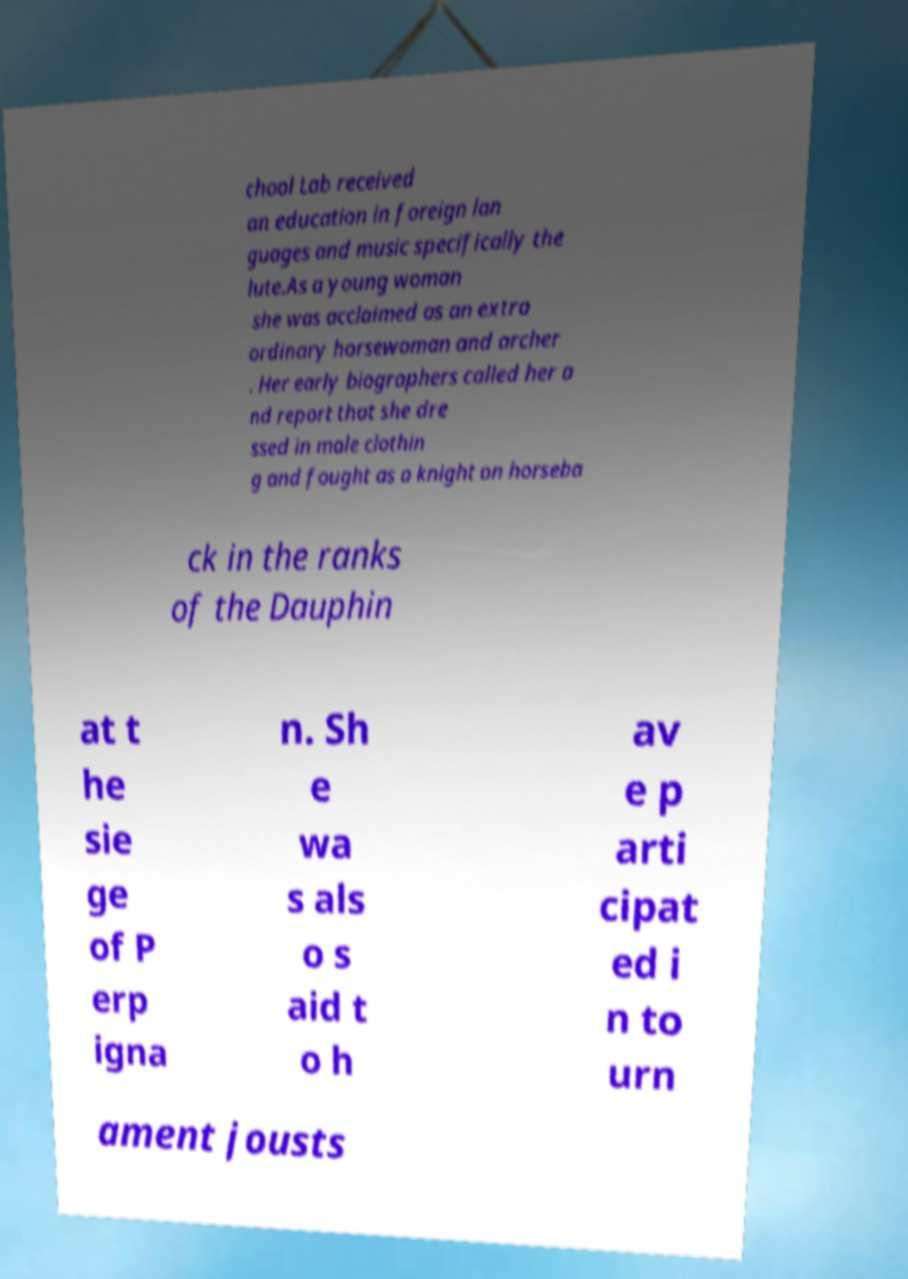For documentation purposes, I need the text within this image transcribed. Could you provide that? chool Lab received an education in foreign lan guages and music specifically the lute.As a young woman she was acclaimed as an extra ordinary horsewoman and archer . Her early biographers called her a nd report that she dre ssed in male clothin g and fought as a knight on horseba ck in the ranks of the Dauphin at t he sie ge of P erp igna n. Sh e wa s als o s aid t o h av e p arti cipat ed i n to urn ament jousts 